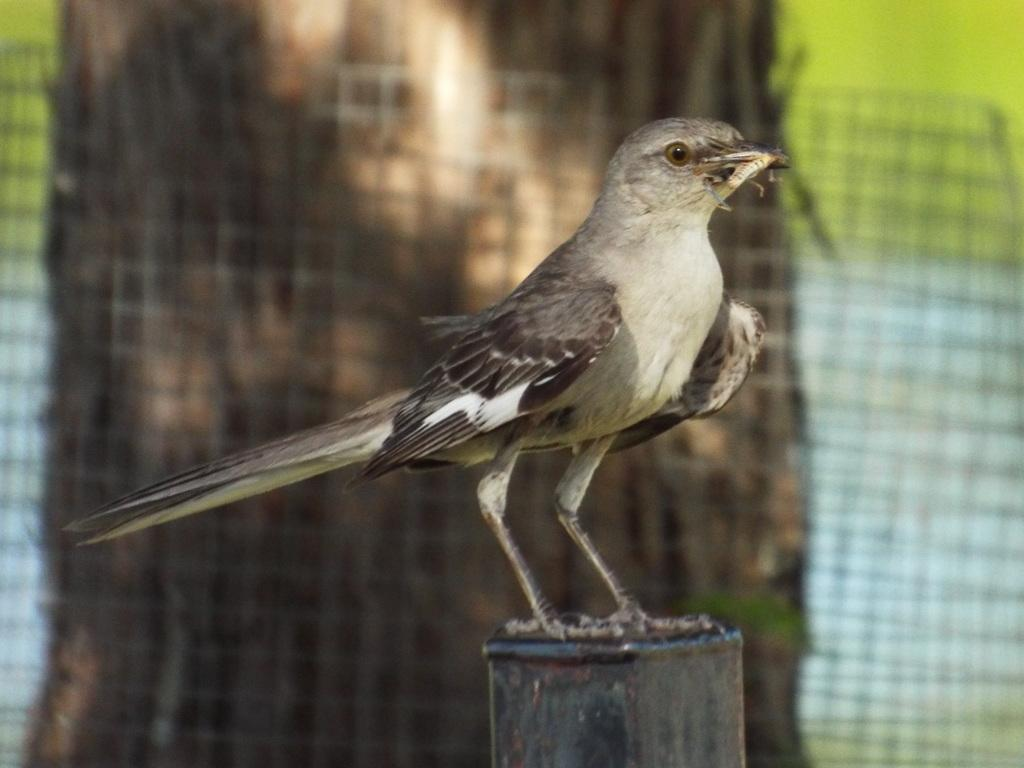What type of animal can be seen in the image? There is a bird in the image. What is the bird doing in the image? The bird is standing. What can be seen around the bark of the tree in the image? There is an iron net around the bark of a tree in the image. How many eggs are visible in the image? There are no eggs visible in the image. What type of error can be seen in the image? There is no error present in the image. 